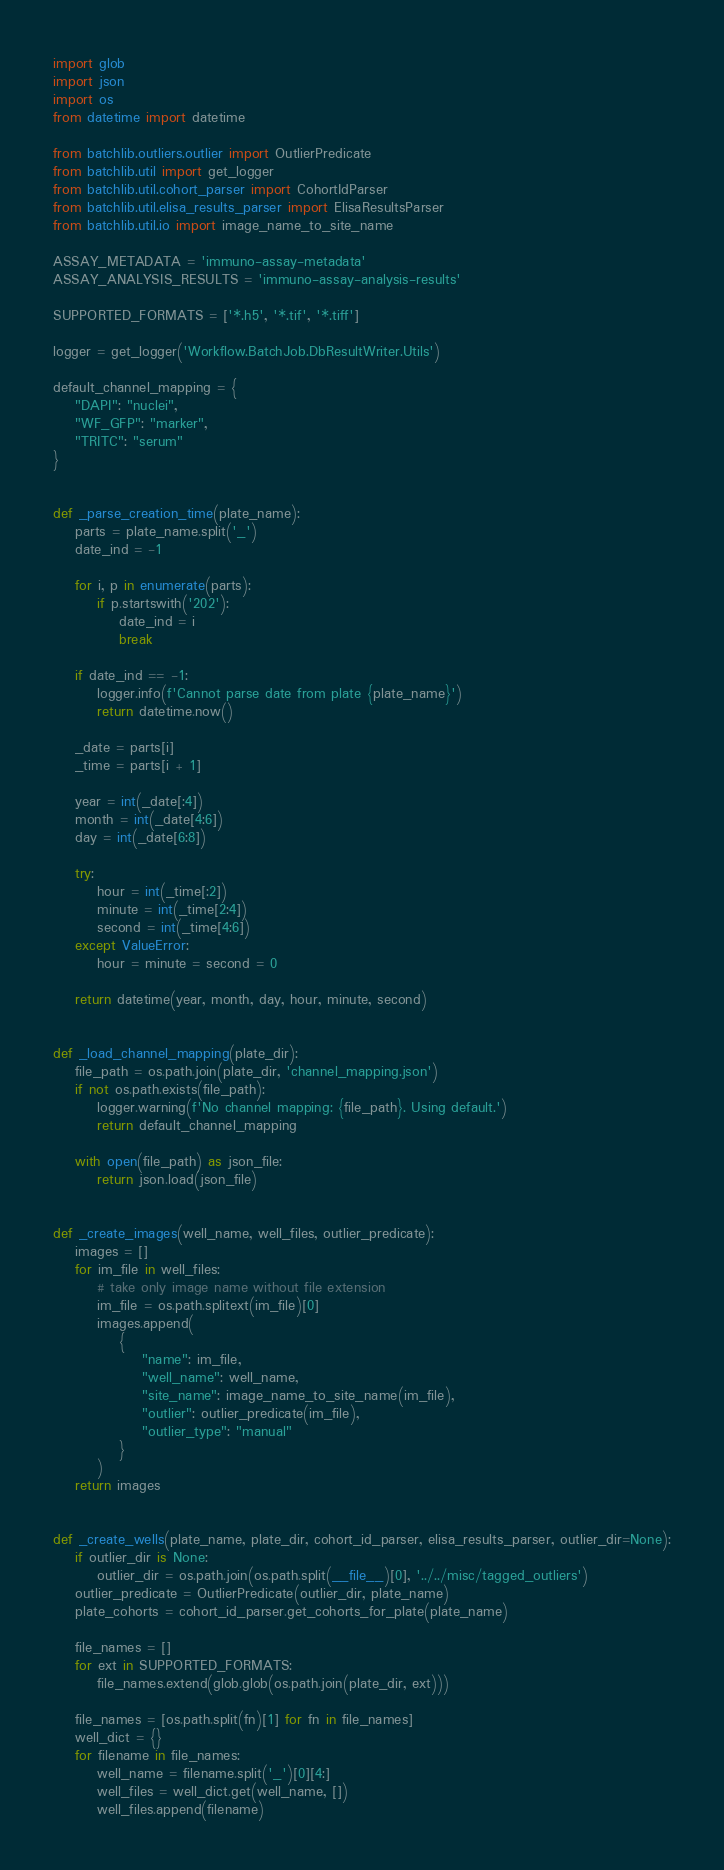Convert code to text. <code><loc_0><loc_0><loc_500><loc_500><_Python_>import glob
import json
import os
from datetime import datetime

from batchlib.outliers.outlier import OutlierPredicate
from batchlib.util import get_logger
from batchlib.util.cohort_parser import CohortIdParser
from batchlib.util.elisa_results_parser import ElisaResultsParser
from batchlib.util.io import image_name_to_site_name

ASSAY_METADATA = 'immuno-assay-metadata'
ASSAY_ANALYSIS_RESULTS = 'immuno-assay-analysis-results'

SUPPORTED_FORMATS = ['*.h5', '*.tif', '*.tiff']

logger = get_logger('Workflow.BatchJob.DbResultWriter.Utils')

default_channel_mapping = {
    "DAPI": "nuclei",
    "WF_GFP": "marker",
    "TRITC": "serum"
}


def _parse_creation_time(plate_name):
    parts = plate_name.split('_')
    date_ind = -1

    for i, p in enumerate(parts):
        if p.startswith('202'):
            date_ind = i
            break

    if date_ind == -1:
        logger.info(f'Cannot parse date from plate {plate_name}')
        return datetime.now()

    _date = parts[i]
    _time = parts[i + 1]

    year = int(_date[:4])
    month = int(_date[4:6])
    day = int(_date[6:8])

    try:
        hour = int(_time[:2])
        minute = int(_time[2:4])
        second = int(_time[4:6])
    except ValueError:
        hour = minute = second = 0

    return datetime(year, month, day, hour, minute, second)


def _load_channel_mapping(plate_dir):
    file_path = os.path.join(plate_dir, 'channel_mapping.json')
    if not os.path.exists(file_path):
        logger.warning(f'No channel mapping: {file_path}. Using default.')
        return default_channel_mapping

    with open(file_path) as json_file:
        return json.load(json_file)


def _create_images(well_name, well_files, outlier_predicate):
    images = []
    for im_file in well_files:
        # take only image name without file extension
        im_file = os.path.splitext(im_file)[0]
        images.append(
            {
                "name": im_file,
                "well_name": well_name,
                "site_name": image_name_to_site_name(im_file),
                "outlier": outlier_predicate(im_file),
                "outlier_type": "manual"
            }
        )
    return images


def _create_wells(plate_name, plate_dir, cohort_id_parser, elisa_results_parser, outlier_dir=None):
    if outlier_dir is None:
        outlier_dir = os.path.join(os.path.split(__file__)[0], '../../misc/tagged_outliers')
    outlier_predicate = OutlierPredicate(outlier_dir, plate_name)
    plate_cohorts = cohort_id_parser.get_cohorts_for_plate(plate_name)

    file_names = []
    for ext in SUPPORTED_FORMATS:
        file_names.extend(glob.glob(os.path.join(plate_dir, ext)))

    file_names = [os.path.split(fn)[1] for fn in file_names]
    well_dict = {}
    for filename in file_names:
        well_name = filename.split('_')[0][4:]
        well_files = well_dict.get(well_name, [])
        well_files.append(filename)</code> 